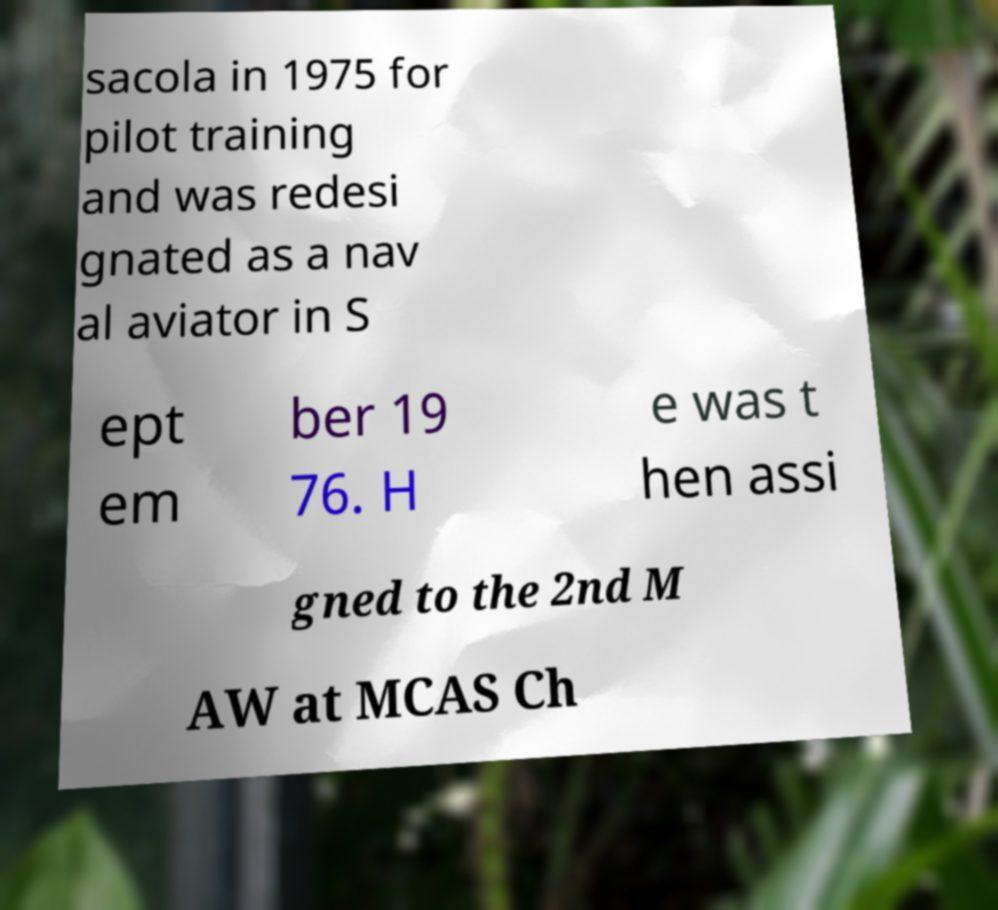Please read and relay the text visible in this image. What does it say? sacola in 1975 for pilot training and was redesi gnated as a nav al aviator in S ept em ber 19 76. H e was t hen assi gned to the 2nd M AW at MCAS Ch 